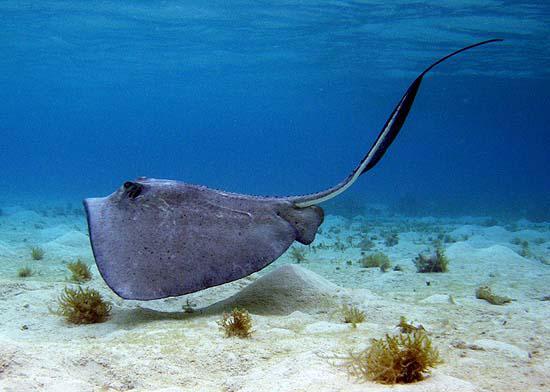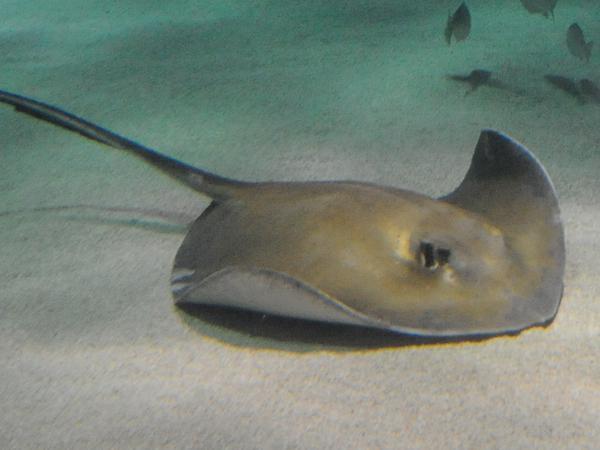The first image is the image on the left, the second image is the image on the right. Considering the images on both sides, is "An image shows one stingray facing rightward, which is not covered with sand." valid? Answer yes or no. Yes. The first image is the image on the left, the second image is the image on the right. Evaluate the accuracy of this statement regarding the images: "There's a blue ray and a brown/grey ray, swimming over smooth sand.". Is it true? Answer yes or no. Yes. 